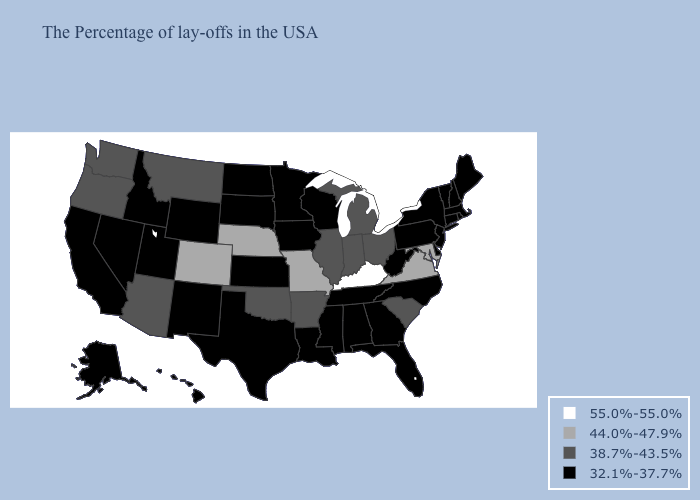Name the states that have a value in the range 55.0%-55.0%?
Answer briefly. Kentucky. Which states have the lowest value in the West?
Quick response, please. Wyoming, New Mexico, Utah, Idaho, Nevada, California, Alaska, Hawaii. Name the states that have a value in the range 44.0%-47.9%?
Give a very brief answer. Maryland, Virginia, Missouri, Nebraska, Colorado. What is the value of Oklahoma?
Keep it brief. 38.7%-43.5%. Does Kentucky have the highest value in the USA?
Answer briefly. Yes. Does Arkansas have the same value as Minnesota?
Give a very brief answer. No. Does Missouri have a lower value than Kentucky?
Be succinct. Yes. What is the highest value in states that border Mississippi?
Answer briefly. 38.7%-43.5%. What is the highest value in the USA?
Short answer required. 55.0%-55.0%. What is the highest value in the West ?
Quick response, please. 44.0%-47.9%. Name the states that have a value in the range 38.7%-43.5%?
Concise answer only. South Carolina, Ohio, Michigan, Indiana, Illinois, Arkansas, Oklahoma, Montana, Arizona, Washington, Oregon. What is the value of Mississippi?
Concise answer only. 32.1%-37.7%. Name the states that have a value in the range 38.7%-43.5%?
Be succinct. South Carolina, Ohio, Michigan, Indiana, Illinois, Arkansas, Oklahoma, Montana, Arizona, Washington, Oregon. What is the value of Illinois?
Short answer required. 38.7%-43.5%. 